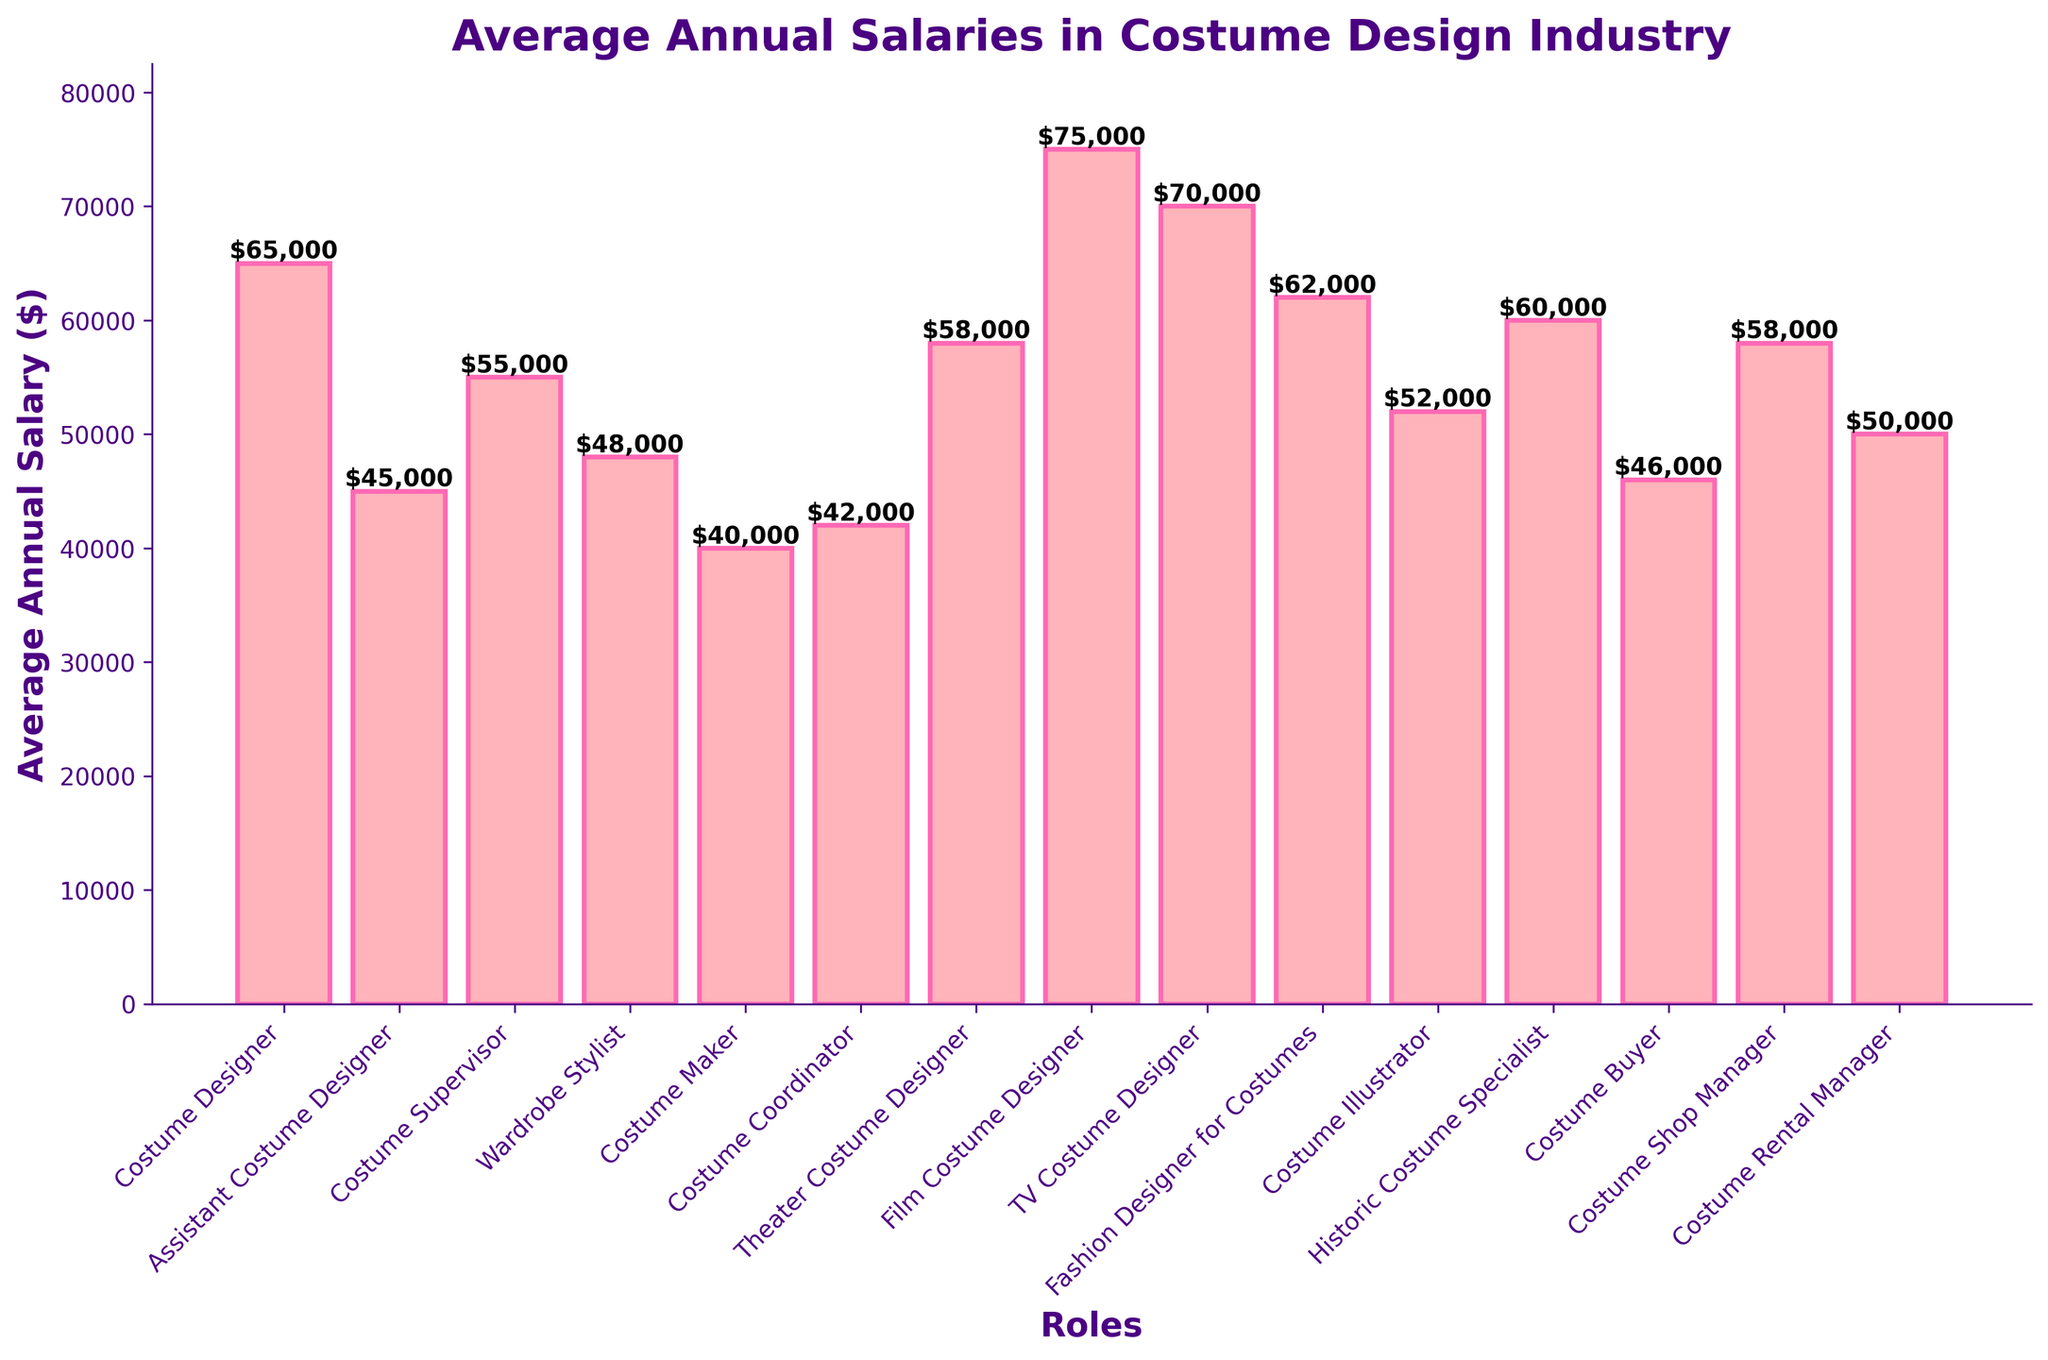What's the role with the highest average annual salary? The role with the highest salary can be identified by the tallest bar in the plot. The tallest bar corresponds to the "Film Costume Designer" with an annual salary of $75,000.
Answer: Film Costume Designer What's the difference in average annual salary between a Costume Designer and an Assistant Costume Designer? The salary of a Costume Designer is $65,000, while that of an Assistant Costume Designer is $45,000. The difference is calculated as $65,000 - $45,000 = $20,000.
Answer: $20,000 Which roles have an average annual salary greater than $60,000? The bars higher than the $60,000 mark correspond to "Costume Designer," "Film Costume Designer," "TV Costume Designer," "Fashion Designer for Costumes," and "Historic Costume Specialist."
Answer: Costume Designer, Film Costume Designer, TV Costume Designer, Fashion Designer for Costumes, Historic Costume Specialist What is the average salary for Theatre Costume Designer and TV Costume Designer combined? The Theatre Costume Designer earns $58,000, and the TV Costume Designer earns $70,000. The combined average is calculated as ($58,000 + $70,000) / 2 = $64,000.
Answer: $64,000 Among Costume Buyer, Costume Shop Manager, and Costume Rental Manager, which role has the highest average salary? By looking at the bars corresponding to these roles, Costume Shop Manager has the highest salary of $58,000. Costume Buyer earns $46,000, and Costume Rental Manager earns $50,000.
Answer: Costume Shop Manager What visual characteristics help differentiate the height of the salaries? Bars with higher salaries are taller and labeled with text showing the exact salary amounts. For example, the bar for "Film Costume Designer" is the tallest, clearly indicating it has the highest salary.
Answer: Taller bars with text labels What's the ratio of the average annual salary of a Wardrobe Stylist to a Costume Maker? The average salary of a Wardrobe Stylist is $48,000, and that of a Costume Maker is $40,000. The ratio is $48,000 / $40,000 = 1.2.
Answer: 1.2 If you were to rank the roles based on their average salaries, which role would be in the middle? To find the median role, list the roles' salaries in ascending order and find the middle point. With 15 roles, the 8th role is "Costume Illustrator" with $52,000.
Answer: Costume Illustrator How much more does a Historic Costume Specialist make compared to a Costume Coordinator? A Historic Costume Specialist earns $60,000, and a Costume Coordinator earns $42,000. The difference is $60,000 - $42,000 = $18,000.
Answer: $18,000 